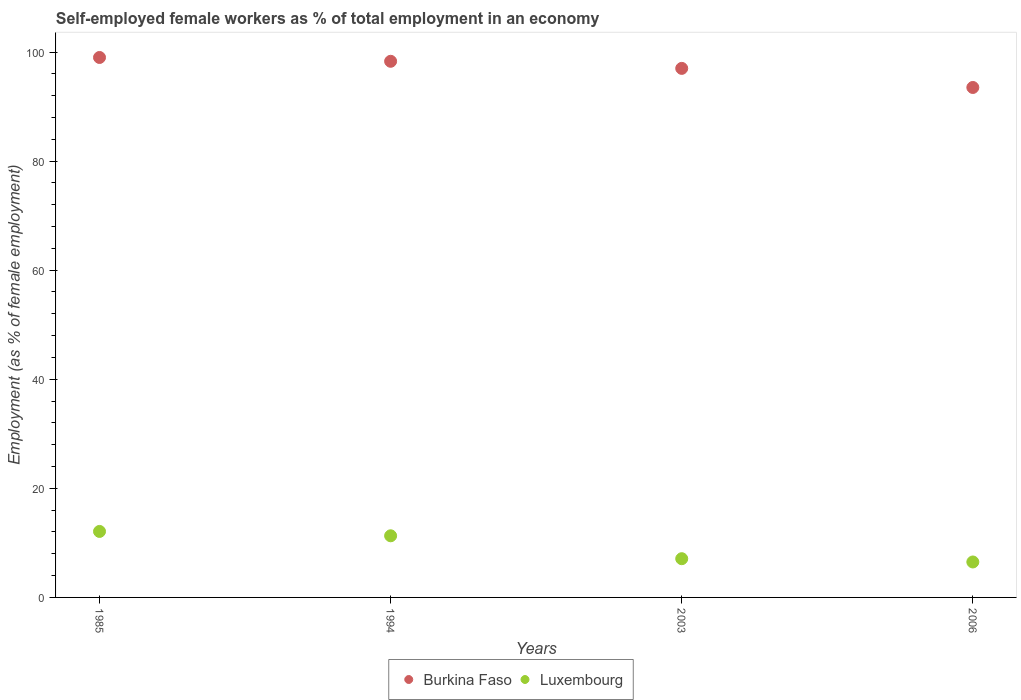How many different coloured dotlines are there?
Keep it short and to the point. 2. What is the percentage of self-employed female workers in Luxembourg in 1985?
Provide a succinct answer. 12.1. Across all years, what is the maximum percentage of self-employed female workers in Burkina Faso?
Make the answer very short. 99. Across all years, what is the minimum percentage of self-employed female workers in Luxembourg?
Your answer should be compact. 6.5. In which year was the percentage of self-employed female workers in Luxembourg maximum?
Give a very brief answer. 1985. In which year was the percentage of self-employed female workers in Luxembourg minimum?
Make the answer very short. 2006. What is the total percentage of self-employed female workers in Burkina Faso in the graph?
Provide a short and direct response. 387.8. What is the difference between the percentage of self-employed female workers in Luxembourg in 1994 and that in 2003?
Offer a very short reply. 4.2. What is the difference between the percentage of self-employed female workers in Luxembourg in 1985 and the percentage of self-employed female workers in Burkina Faso in 1994?
Keep it short and to the point. -86.2. What is the average percentage of self-employed female workers in Burkina Faso per year?
Give a very brief answer. 96.95. What is the ratio of the percentage of self-employed female workers in Luxembourg in 1985 to that in 1994?
Provide a succinct answer. 1.07. What is the difference between the highest and the second highest percentage of self-employed female workers in Burkina Faso?
Offer a terse response. 0.7. What is the difference between the highest and the lowest percentage of self-employed female workers in Luxembourg?
Offer a terse response. 5.6. In how many years, is the percentage of self-employed female workers in Burkina Faso greater than the average percentage of self-employed female workers in Burkina Faso taken over all years?
Give a very brief answer. 3. Does the percentage of self-employed female workers in Luxembourg monotonically increase over the years?
Provide a succinct answer. No. Is the percentage of self-employed female workers in Burkina Faso strictly greater than the percentage of self-employed female workers in Luxembourg over the years?
Make the answer very short. Yes. Is the percentage of self-employed female workers in Luxembourg strictly less than the percentage of self-employed female workers in Burkina Faso over the years?
Give a very brief answer. Yes. How many dotlines are there?
Your answer should be compact. 2. What is the difference between two consecutive major ticks on the Y-axis?
Your answer should be compact. 20. Are the values on the major ticks of Y-axis written in scientific E-notation?
Your answer should be compact. No. Where does the legend appear in the graph?
Ensure brevity in your answer.  Bottom center. How are the legend labels stacked?
Your answer should be compact. Horizontal. What is the title of the graph?
Your answer should be very brief. Self-employed female workers as % of total employment in an economy. Does "Peru" appear as one of the legend labels in the graph?
Your answer should be very brief. No. What is the label or title of the Y-axis?
Your answer should be very brief. Employment (as % of female employment). What is the Employment (as % of female employment) in Luxembourg in 1985?
Your answer should be compact. 12.1. What is the Employment (as % of female employment) of Burkina Faso in 1994?
Make the answer very short. 98.3. What is the Employment (as % of female employment) of Luxembourg in 1994?
Keep it short and to the point. 11.3. What is the Employment (as % of female employment) of Burkina Faso in 2003?
Keep it short and to the point. 97. What is the Employment (as % of female employment) in Luxembourg in 2003?
Provide a succinct answer. 7.1. What is the Employment (as % of female employment) in Burkina Faso in 2006?
Provide a short and direct response. 93.5. What is the Employment (as % of female employment) of Luxembourg in 2006?
Your response must be concise. 6.5. Across all years, what is the maximum Employment (as % of female employment) in Burkina Faso?
Offer a very short reply. 99. Across all years, what is the maximum Employment (as % of female employment) of Luxembourg?
Your answer should be compact. 12.1. Across all years, what is the minimum Employment (as % of female employment) of Burkina Faso?
Provide a short and direct response. 93.5. Across all years, what is the minimum Employment (as % of female employment) in Luxembourg?
Your answer should be very brief. 6.5. What is the total Employment (as % of female employment) in Burkina Faso in the graph?
Your response must be concise. 387.8. What is the total Employment (as % of female employment) of Luxembourg in the graph?
Keep it short and to the point. 37. What is the difference between the Employment (as % of female employment) in Burkina Faso in 1985 and that in 1994?
Offer a terse response. 0.7. What is the difference between the Employment (as % of female employment) of Luxembourg in 1985 and that in 1994?
Give a very brief answer. 0.8. What is the difference between the Employment (as % of female employment) in Luxembourg in 1985 and that in 2003?
Your answer should be compact. 5. What is the difference between the Employment (as % of female employment) in Burkina Faso in 1985 and that in 2006?
Give a very brief answer. 5.5. What is the difference between the Employment (as % of female employment) in Burkina Faso in 1994 and that in 2003?
Provide a succinct answer. 1.3. What is the difference between the Employment (as % of female employment) in Burkina Faso in 1994 and that in 2006?
Provide a succinct answer. 4.8. What is the difference between the Employment (as % of female employment) in Luxembourg in 1994 and that in 2006?
Give a very brief answer. 4.8. What is the difference between the Employment (as % of female employment) of Burkina Faso in 1985 and the Employment (as % of female employment) of Luxembourg in 1994?
Your answer should be very brief. 87.7. What is the difference between the Employment (as % of female employment) of Burkina Faso in 1985 and the Employment (as % of female employment) of Luxembourg in 2003?
Your answer should be very brief. 91.9. What is the difference between the Employment (as % of female employment) of Burkina Faso in 1985 and the Employment (as % of female employment) of Luxembourg in 2006?
Your response must be concise. 92.5. What is the difference between the Employment (as % of female employment) of Burkina Faso in 1994 and the Employment (as % of female employment) of Luxembourg in 2003?
Offer a very short reply. 91.2. What is the difference between the Employment (as % of female employment) in Burkina Faso in 1994 and the Employment (as % of female employment) in Luxembourg in 2006?
Your response must be concise. 91.8. What is the difference between the Employment (as % of female employment) of Burkina Faso in 2003 and the Employment (as % of female employment) of Luxembourg in 2006?
Offer a very short reply. 90.5. What is the average Employment (as % of female employment) in Burkina Faso per year?
Provide a succinct answer. 96.95. What is the average Employment (as % of female employment) of Luxembourg per year?
Your answer should be very brief. 9.25. In the year 1985, what is the difference between the Employment (as % of female employment) of Burkina Faso and Employment (as % of female employment) of Luxembourg?
Offer a terse response. 86.9. In the year 2003, what is the difference between the Employment (as % of female employment) of Burkina Faso and Employment (as % of female employment) of Luxembourg?
Your answer should be compact. 89.9. What is the ratio of the Employment (as % of female employment) in Burkina Faso in 1985 to that in 1994?
Give a very brief answer. 1.01. What is the ratio of the Employment (as % of female employment) of Luxembourg in 1985 to that in 1994?
Provide a succinct answer. 1.07. What is the ratio of the Employment (as % of female employment) of Burkina Faso in 1985 to that in 2003?
Your answer should be compact. 1.02. What is the ratio of the Employment (as % of female employment) of Luxembourg in 1985 to that in 2003?
Make the answer very short. 1.7. What is the ratio of the Employment (as % of female employment) in Burkina Faso in 1985 to that in 2006?
Give a very brief answer. 1.06. What is the ratio of the Employment (as % of female employment) in Luxembourg in 1985 to that in 2006?
Provide a short and direct response. 1.86. What is the ratio of the Employment (as % of female employment) in Burkina Faso in 1994 to that in 2003?
Your answer should be very brief. 1.01. What is the ratio of the Employment (as % of female employment) of Luxembourg in 1994 to that in 2003?
Give a very brief answer. 1.59. What is the ratio of the Employment (as % of female employment) of Burkina Faso in 1994 to that in 2006?
Offer a very short reply. 1.05. What is the ratio of the Employment (as % of female employment) of Luxembourg in 1994 to that in 2006?
Your response must be concise. 1.74. What is the ratio of the Employment (as % of female employment) of Burkina Faso in 2003 to that in 2006?
Your answer should be compact. 1.04. What is the ratio of the Employment (as % of female employment) of Luxembourg in 2003 to that in 2006?
Offer a terse response. 1.09. What is the difference between the highest and the lowest Employment (as % of female employment) in Luxembourg?
Your answer should be compact. 5.6. 